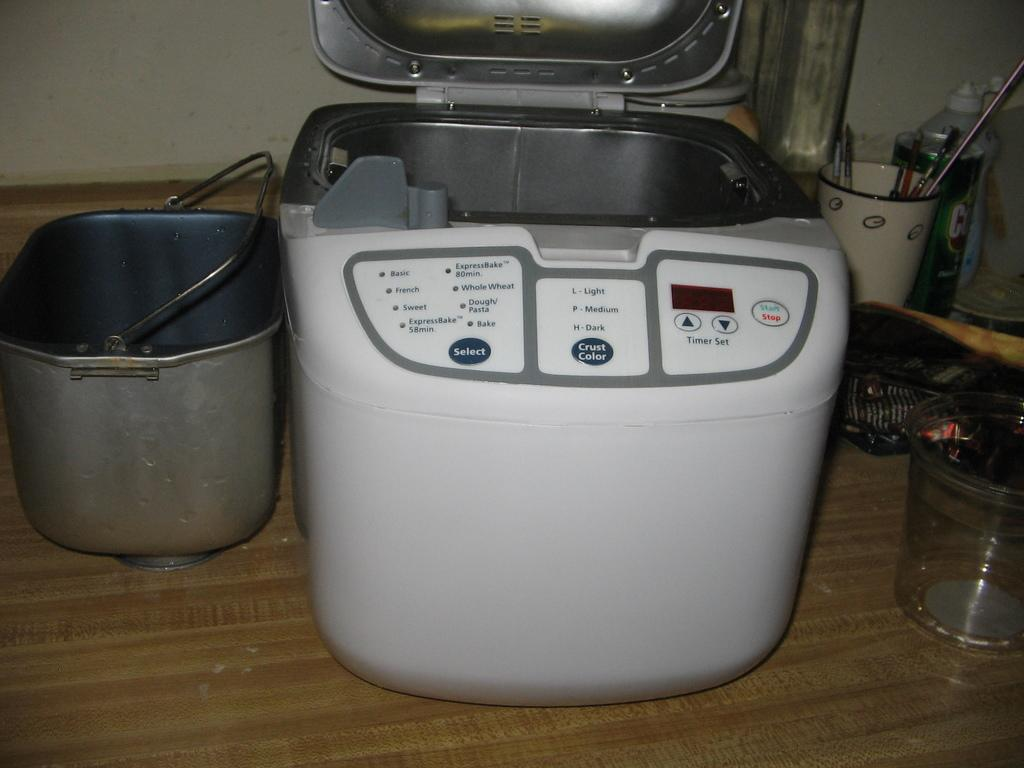<image>
Give a short and clear explanation of the subsequent image. A deep fat fryer has the settings for a crust colour as Light, Medium and Dark to choose from. 